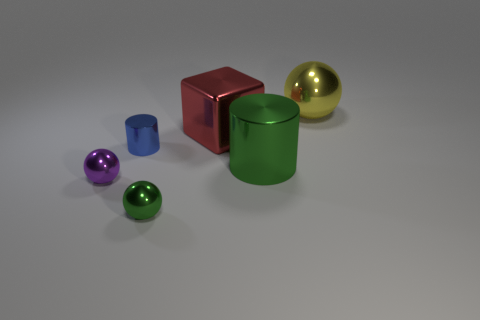Add 4 large purple matte cylinders. How many objects exist? 10 Subtract all cylinders. How many objects are left? 4 Add 4 small green things. How many small green things exist? 5 Subtract 0 brown balls. How many objects are left? 6 Subtract all large red blocks. Subtract all red balls. How many objects are left? 5 Add 4 green shiny things. How many green shiny things are left? 6 